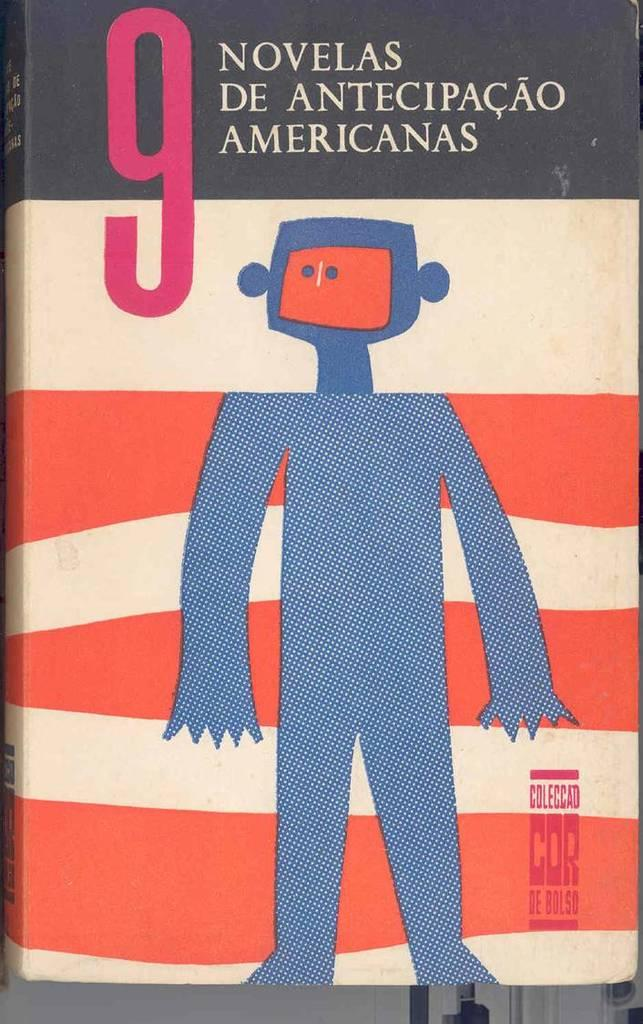What object can be seen in the image? There is a book in the image. What is depicted on the book cover? The book cover has a painting of a cartoon. What type of meal is being prepared on the plastic table in the image? There is no meal or plastic table present in the image; it only features a book with a cartoon painting on the cover. 